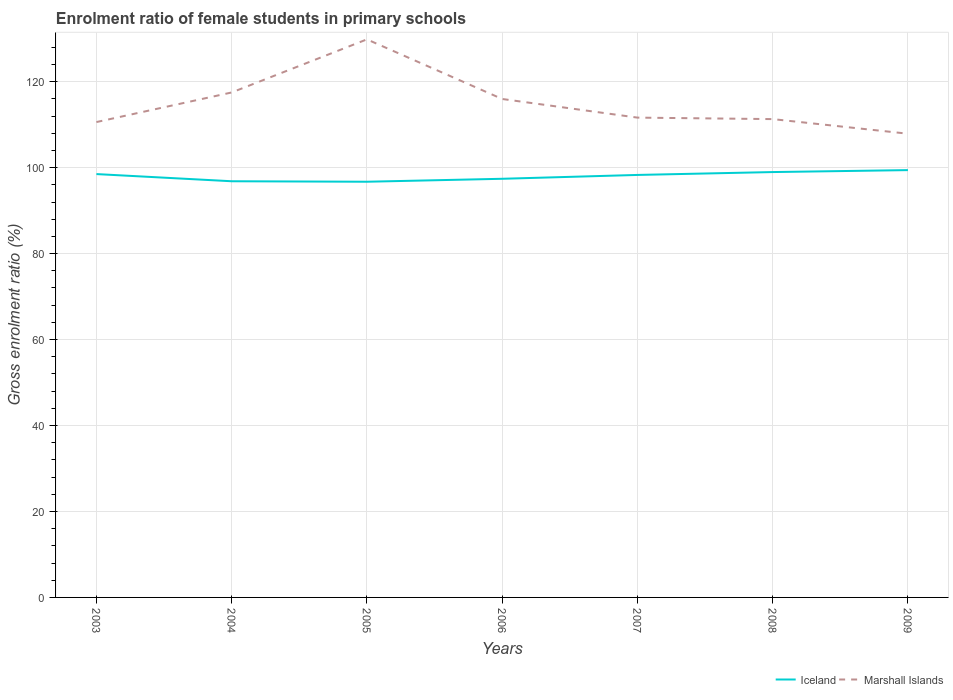How many different coloured lines are there?
Offer a very short reply. 2. Across all years, what is the maximum enrolment ratio of female students in primary schools in Marshall Islands?
Provide a succinct answer. 107.9. What is the total enrolment ratio of female students in primary schools in Iceland in the graph?
Ensure brevity in your answer.  -1.47. What is the difference between the highest and the second highest enrolment ratio of female students in primary schools in Marshall Islands?
Your answer should be compact. 21.95. What is the difference between the highest and the lowest enrolment ratio of female students in primary schools in Iceland?
Your answer should be very brief. 4. What is the difference between two consecutive major ticks on the Y-axis?
Provide a succinct answer. 20. Does the graph contain any zero values?
Provide a short and direct response. No. What is the title of the graph?
Give a very brief answer. Enrolment ratio of female students in primary schools. What is the label or title of the X-axis?
Your response must be concise. Years. What is the label or title of the Y-axis?
Make the answer very short. Gross enrolment ratio (%). What is the Gross enrolment ratio (%) of Iceland in 2003?
Keep it short and to the point. 98.51. What is the Gross enrolment ratio (%) of Marshall Islands in 2003?
Your answer should be very brief. 110.61. What is the Gross enrolment ratio (%) in Iceland in 2004?
Your answer should be very brief. 96.84. What is the Gross enrolment ratio (%) in Marshall Islands in 2004?
Offer a very short reply. 117.5. What is the Gross enrolment ratio (%) in Iceland in 2005?
Offer a terse response. 96.73. What is the Gross enrolment ratio (%) in Marshall Islands in 2005?
Your response must be concise. 129.85. What is the Gross enrolment ratio (%) in Iceland in 2006?
Give a very brief answer. 97.41. What is the Gross enrolment ratio (%) in Marshall Islands in 2006?
Ensure brevity in your answer.  115.98. What is the Gross enrolment ratio (%) in Iceland in 2007?
Ensure brevity in your answer.  98.31. What is the Gross enrolment ratio (%) of Marshall Islands in 2007?
Provide a short and direct response. 111.64. What is the Gross enrolment ratio (%) of Iceland in 2008?
Your answer should be very brief. 98.98. What is the Gross enrolment ratio (%) of Marshall Islands in 2008?
Make the answer very short. 111.3. What is the Gross enrolment ratio (%) in Iceland in 2009?
Ensure brevity in your answer.  99.43. What is the Gross enrolment ratio (%) of Marshall Islands in 2009?
Offer a very short reply. 107.9. Across all years, what is the maximum Gross enrolment ratio (%) in Iceland?
Offer a very short reply. 99.43. Across all years, what is the maximum Gross enrolment ratio (%) in Marshall Islands?
Ensure brevity in your answer.  129.85. Across all years, what is the minimum Gross enrolment ratio (%) of Iceland?
Offer a terse response. 96.73. Across all years, what is the minimum Gross enrolment ratio (%) of Marshall Islands?
Your response must be concise. 107.9. What is the total Gross enrolment ratio (%) of Iceland in the graph?
Ensure brevity in your answer.  686.2. What is the total Gross enrolment ratio (%) in Marshall Islands in the graph?
Offer a very short reply. 804.78. What is the difference between the Gross enrolment ratio (%) of Iceland in 2003 and that in 2004?
Your answer should be compact. 1.67. What is the difference between the Gross enrolment ratio (%) in Marshall Islands in 2003 and that in 2004?
Provide a succinct answer. -6.89. What is the difference between the Gross enrolment ratio (%) in Iceland in 2003 and that in 2005?
Provide a short and direct response. 1.78. What is the difference between the Gross enrolment ratio (%) of Marshall Islands in 2003 and that in 2005?
Provide a short and direct response. -19.24. What is the difference between the Gross enrolment ratio (%) of Iceland in 2003 and that in 2006?
Provide a succinct answer. 1.09. What is the difference between the Gross enrolment ratio (%) of Marshall Islands in 2003 and that in 2006?
Keep it short and to the point. -5.37. What is the difference between the Gross enrolment ratio (%) in Iceland in 2003 and that in 2007?
Offer a very short reply. 0.2. What is the difference between the Gross enrolment ratio (%) of Marshall Islands in 2003 and that in 2007?
Your answer should be compact. -1.03. What is the difference between the Gross enrolment ratio (%) of Iceland in 2003 and that in 2008?
Give a very brief answer. -0.47. What is the difference between the Gross enrolment ratio (%) in Marshall Islands in 2003 and that in 2008?
Ensure brevity in your answer.  -0.69. What is the difference between the Gross enrolment ratio (%) in Iceland in 2003 and that in 2009?
Offer a very short reply. -0.92. What is the difference between the Gross enrolment ratio (%) of Marshall Islands in 2003 and that in 2009?
Offer a very short reply. 2.71. What is the difference between the Gross enrolment ratio (%) in Iceland in 2004 and that in 2005?
Your answer should be very brief. 0.11. What is the difference between the Gross enrolment ratio (%) in Marshall Islands in 2004 and that in 2005?
Provide a short and direct response. -12.35. What is the difference between the Gross enrolment ratio (%) of Iceland in 2004 and that in 2006?
Make the answer very short. -0.57. What is the difference between the Gross enrolment ratio (%) in Marshall Islands in 2004 and that in 2006?
Provide a short and direct response. 1.52. What is the difference between the Gross enrolment ratio (%) of Iceland in 2004 and that in 2007?
Keep it short and to the point. -1.47. What is the difference between the Gross enrolment ratio (%) of Marshall Islands in 2004 and that in 2007?
Provide a short and direct response. 5.85. What is the difference between the Gross enrolment ratio (%) in Iceland in 2004 and that in 2008?
Offer a very short reply. -2.14. What is the difference between the Gross enrolment ratio (%) of Marshall Islands in 2004 and that in 2008?
Ensure brevity in your answer.  6.2. What is the difference between the Gross enrolment ratio (%) of Iceland in 2004 and that in 2009?
Keep it short and to the point. -2.59. What is the difference between the Gross enrolment ratio (%) in Marshall Islands in 2004 and that in 2009?
Ensure brevity in your answer.  9.6. What is the difference between the Gross enrolment ratio (%) in Iceland in 2005 and that in 2006?
Your answer should be compact. -0.69. What is the difference between the Gross enrolment ratio (%) of Marshall Islands in 2005 and that in 2006?
Keep it short and to the point. 13.87. What is the difference between the Gross enrolment ratio (%) in Iceland in 2005 and that in 2007?
Provide a short and direct response. -1.58. What is the difference between the Gross enrolment ratio (%) in Marshall Islands in 2005 and that in 2007?
Offer a terse response. 18.21. What is the difference between the Gross enrolment ratio (%) of Iceland in 2005 and that in 2008?
Offer a terse response. -2.25. What is the difference between the Gross enrolment ratio (%) in Marshall Islands in 2005 and that in 2008?
Your answer should be very brief. 18.55. What is the difference between the Gross enrolment ratio (%) in Iceland in 2005 and that in 2009?
Ensure brevity in your answer.  -2.7. What is the difference between the Gross enrolment ratio (%) of Marshall Islands in 2005 and that in 2009?
Offer a very short reply. 21.95. What is the difference between the Gross enrolment ratio (%) in Iceland in 2006 and that in 2007?
Your answer should be very brief. -0.9. What is the difference between the Gross enrolment ratio (%) of Marshall Islands in 2006 and that in 2007?
Your response must be concise. 4.34. What is the difference between the Gross enrolment ratio (%) of Iceland in 2006 and that in 2008?
Provide a succinct answer. -1.56. What is the difference between the Gross enrolment ratio (%) in Marshall Islands in 2006 and that in 2008?
Offer a very short reply. 4.68. What is the difference between the Gross enrolment ratio (%) of Iceland in 2006 and that in 2009?
Offer a very short reply. -2.02. What is the difference between the Gross enrolment ratio (%) in Marshall Islands in 2006 and that in 2009?
Ensure brevity in your answer.  8.08. What is the difference between the Gross enrolment ratio (%) in Iceland in 2007 and that in 2008?
Your answer should be very brief. -0.67. What is the difference between the Gross enrolment ratio (%) of Marshall Islands in 2007 and that in 2008?
Offer a terse response. 0.35. What is the difference between the Gross enrolment ratio (%) of Iceland in 2007 and that in 2009?
Your answer should be compact. -1.12. What is the difference between the Gross enrolment ratio (%) of Marshall Islands in 2007 and that in 2009?
Make the answer very short. 3.74. What is the difference between the Gross enrolment ratio (%) of Iceland in 2008 and that in 2009?
Make the answer very short. -0.45. What is the difference between the Gross enrolment ratio (%) in Marshall Islands in 2008 and that in 2009?
Give a very brief answer. 3.4. What is the difference between the Gross enrolment ratio (%) of Iceland in 2003 and the Gross enrolment ratio (%) of Marshall Islands in 2004?
Provide a succinct answer. -18.99. What is the difference between the Gross enrolment ratio (%) in Iceland in 2003 and the Gross enrolment ratio (%) in Marshall Islands in 2005?
Keep it short and to the point. -31.34. What is the difference between the Gross enrolment ratio (%) of Iceland in 2003 and the Gross enrolment ratio (%) of Marshall Islands in 2006?
Make the answer very short. -17.47. What is the difference between the Gross enrolment ratio (%) in Iceland in 2003 and the Gross enrolment ratio (%) in Marshall Islands in 2007?
Offer a terse response. -13.14. What is the difference between the Gross enrolment ratio (%) in Iceland in 2003 and the Gross enrolment ratio (%) in Marshall Islands in 2008?
Provide a short and direct response. -12.79. What is the difference between the Gross enrolment ratio (%) in Iceland in 2003 and the Gross enrolment ratio (%) in Marshall Islands in 2009?
Provide a short and direct response. -9.39. What is the difference between the Gross enrolment ratio (%) of Iceland in 2004 and the Gross enrolment ratio (%) of Marshall Islands in 2005?
Provide a succinct answer. -33.01. What is the difference between the Gross enrolment ratio (%) of Iceland in 2004 and the Gross enrolment ratio (%) of Marshall Islands in 2006?
Your answer should be compact. -19.14. What is the difference between the Gross enrolment ratio (%) of Iceland in 2004 and the Gross enrolment ratio (%) of Marshall Islands in 2007?
Ensure brevity in your answer.  -14.81. What is the difference between the Gross enrolment ratio (%) of Iceland in 2004 and the Gross enrolment ratio (%) of Marshall Islands in 2008?
Provide a succinct answer. -14.46. What is the difference between the Gross enrolment ratio (%) of Iceland in 2004 and the Gross enrolment ratio (%) of Marshall Islands in 2009?
Keep it short and to the point. -11.06. What is the difference between the Gross enrolment ratio (%) in Iceland in 2005 and the Gross enrolment ratio (%) in Marshall Islands in 2006?
Ensure brevity in your answer.  -19.25. What is the difference between the Gross enrolment ratio (%) in Iceland in 2005 and the Gross enrolment ratio (%) in Marshall Islands in 2007?
Provide a short and direct response. -14.92. What is the difference between the Gross enrolment ratio (%) in Iceland in 2005 and the Gross enrolment ratio (%) in Marshall Islands in 2008?
Offer a very short reply. -14.57. What is the difference between the Gross enrolment ratio (%) in Iceland in 2005 and the Gross enrolment ratio (%) in Marshall Islands in 2009?
Your answer should be compact. -11.17. What is the difference between the Gross enrolment ratio (%) of Iceland in 2006 and the Gross enrolment ratio (%) of Marshall Islands in 2007?
Make the answer very short. -14.23. What is the difference between the Gross enrolment ratio (%) in Iceland in 2006 and the Gross enrolment ratio (%) in Marshall Islands in 2008?
Your answer should be very brief. -13.89. What is the difference between the Gross enrolment ratio (%) in Iceland in 2006 and the Gross enrolment ratio (%) in Marshall Islands in 2009?
Make the answer very short. -10.49. What is the difference between the Gross enrolment ratio (%) of Iceland in 2007 and the Gross enrolment ratio (%) of Marshall Islands in 2008?
Ensure brevity in your answer.  -12.99. What is the difference between the Gross enrolment ratio (%) in Iceland in 2007 and the Gross enrolment ratio (%) in Marshall Islands in 2009?
Your response must be concise. -9.59. What is the difference between the Gross enrolment ratio (%) in Iceland in 2008 and the Gross enrolment ratio (%) in Marshall Islands in 2009?
Your answer should be very brief. -8.92. What is the average Gross enrolment ratio (%) in Iceland per year?
Keep it short and to the point. 98.03. What is the average Gross enrolment ratio (%) in Marshall Islands per year?
Your response must be concise. 114.97. In the year 2003, what is the difference between the Gross enrolment ratio (%) of Iceland and Gross enrolment ratio (%) of Marshall Islands?
Your answer should be compact. -12.1. In the year 2004, what is the difference between the Gross enrolment ratio (%) in Iceland and Gross enrolment ratio (%) in Marshall Islands?
Offer a very short reply. -20.66. In the year 2005, what is the difference between the Gross enrolment ratio (%) of Iceland and Gross enrolment ratio (%) of Marshall Islands?
Ensure brevity in your answer.  -33.13. In the year 2006, what is the difference between the Gross enrolment ratio (%) of Iceland and Gross enrolment ratio (%) of Marshall Islands?
Offer a terse response. -18.57. In the year 2007, what is the difference between the Gross enrolment ratio (%) of Iceland and Gross enrolment ratio (%) of Marshall Islands?
Make the answer very short. -13.34. In the year 2008, what is the difference between the Gross enrolment ratio (%) of Iceland and Gross enrolment ratio (%) of Marshall Islands?
Your response must be concise. -12.32. In the year 2009, what is the difference between the Gross enrolment ratio (%) in Iceland and Gross enrolment ratio (%) in Marshall Islands?
Your answer should be compact. -8.47. What is the ratio of the Gross enrolment ratio (%) in Iceland in 2003 to that in 2004?
Keep it short and to the point. 1.02. What is the ratio of the Gross enrolment ratio (%) of Marshall Islands in 2003 to that in 2004?
Keep it short and to the point. 0.94. What is the ratio of the Gross enrolment ratio (%) of Iceland in 2003 to that in 2005?
Provide a short and direct response. 1.02. What is the ratio of the Gross enrolment ratio (%) in Marshall Islands in 2003 to that in 2005?
Offer a very short reply. 0.85. What is the ratio of the Gross enrolment ratio (%) of Iceland in 2003 to that in 2006?
Give a very brief answer. 1.01. What is the ratio of the Gross enrolment ratio (%) of Marshall Islands in 2003 to that in 2006?
Offer a very short reply. 0.95. What is the ratio of the Gross enrolment ratio (%) in Marshall Islands in 2003 to that in 2008?
Offer a very short reply. 0.99. What is the ratio of the Gross enrolment ratio (%) of Marshall Islands in 2003 to that in 2009?
Make the answer very short. 1.03. What is the ratio of the Gross enrolment ratio (%) of Marshall Islands in 2004 to that in 2005?
Provide a succinct answer. 0.9. What is the ratio of the Gross enrolment ratio (%) of Marshall Islands in 2004 to that in 2006?
Ensure brevity in your answer.  1.01. What is the ratio of the Gross enrolment ratio (%) in Iceland in 2004 to that in 2007?
Provide a short and direct response. 0.99. What is the ratio of the Gross enrolment ratio (%) in Marshall Islands in 2004 to that in 2007?
Your answer should be very brief. 1.05. What is the ratio of the Gross enrolment ratio (%) in Iceland in 2004 to that in 2008?
Provide a short and direct response. 0.98. What is the ratio of the Gross enrolment ratio (%) of Marshall Islands in 2004 to that in 2008?
Your answer should be very brief. 1.06. What is the ratio of the Gross enrolment ratio (%) of Iceland in 2004 to that in 2009?
Offer a terse response. 0.97. What is the ratio of the Gross enrolment ratio (%) in Marshall Islands in 2004 to that in 2009?
Make the answer very short. 1.09. What is the ratio of the Gross enrolment ratio (%) of Marshall Islands in 2005 to that in 2006?
Give a very brief answer. 1.12. What is the ratio of the Gross enrolment ratio (%) of Iceland in 2005 to that in 2007?
Provide a short and direct response. 0.98. What is the ratio of the Gross enrolment ratio (%) of Marshall Islands in 2005 to that in 2007?
Your answer should be very brief. 1.16. What is the ratio of the Gross enrolment ratio (%) of Iceland in 2005 to that in 2008?
Your answer should be compact. 0.98. What is the ratio of the Gross enrolment ratio (%) in Marshall Islands in 2005 to that in 2008?
Ensure brevity in your answer.  1.17. What is the ratio of the Gross enrolment ratio (%) in Iceland in 2005 to that in 2009?
Your answer should be very brief. 0.97. What is the ratio of the Gross enrolment ratio (%) of Marshall Islands in 2005 to that in 2009?
Offer a very short reply. 1.2. What is the ratio of the Gross enrolment ratio (%) in Iceland in 2006 to that in 2007?
Provide a short and direct response. 0.99. What is the ratio of the Gross enrolment ratio (%) in Marshall Islands in 2006 to that in 2007?
Your answer should be compact. 1.04. What is the ratio of the Gross enrolment ratio (%) in Iceland in 2006 to that in 2008?
Provide a succinct answer. 0.98. What is the ratio of the Gross enrolment ratio (%) in Marshall Islands in 2006 to that in 2008?
Make the answer very short. 1.04. What is the ratio of the Gross enrolment ratio (%) in Iceland in 2006 to that in 2009?
Your response must be concise. 0.98. What is the ratio of the Gross enrolment ratio (%) in Marshall Islands in 2006 to that in 2009?
Provide a succinct answer. 1.07. What is the ratio of the Gross enrolment ratio (%) in Iceland in 2007 to that in 2009?
Give a very brief answer. 0.99. What is the ratio of the Gross enrolment ratio (%) of Marshall Islands in 2007 to that in 2009?
Your answer should be compact. 1.03. What is the ratio of the Gross enrolment ratio (%) in Marshall Islands in 2008 to that in 2009?
Offer a terse response. 1.03. What is the difference between the highest and the second highest Gross enrolment ratio (%) in Iceland?
Offer a very short reply. 0.45. What is the difference between the highest and the second highest Gross enrolment ratio (%) of Marshall Islands?
Your answer should be very brief. 12.35. What is the difference between the highest and the lowest Gross enrolment ratio (%) in Iceland?
Your answer should be very brief. 2.7. What is the difference between the highest and the lowest Gross enrolment ratio (%) of Marshall Islands?
Offer a terse response. 21.95. 